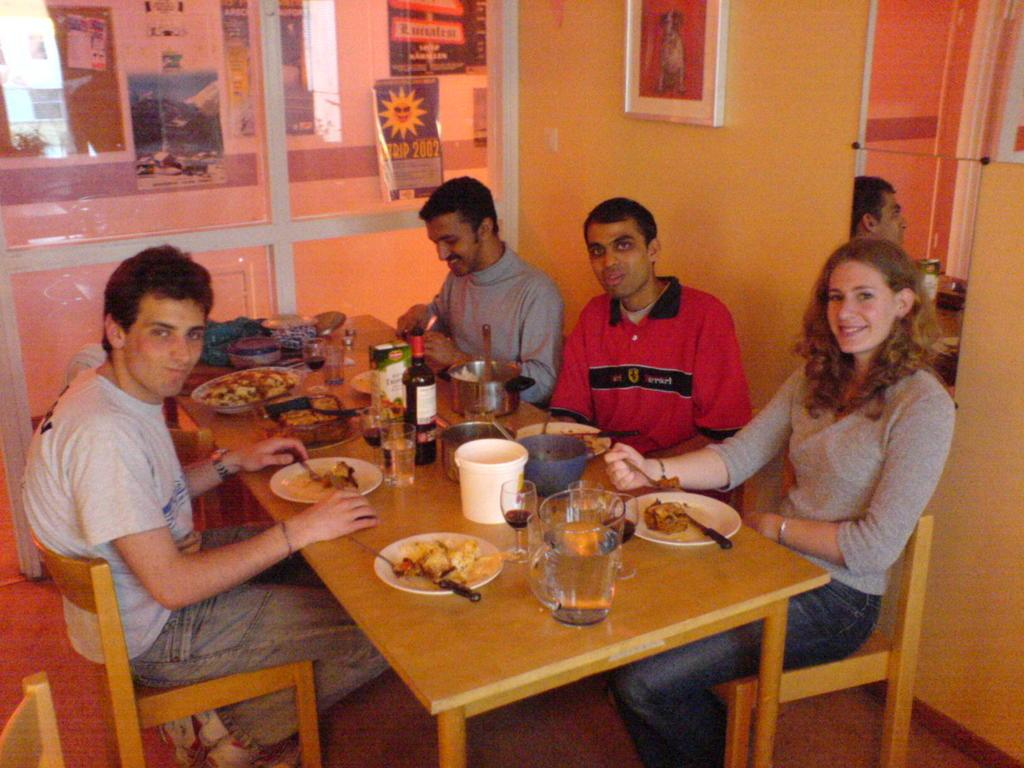How many people are in the image? There is a group of persons in the image. What are the persons doing in the image? The persons are sitting on chairs, having their drinks, and having their food. What type of toothbrush is being used by the person in the image? There is no toothbrush present in the image. Are the persons in the image driving any vehicles? There is no indication of any vehicles or driving in the image. 